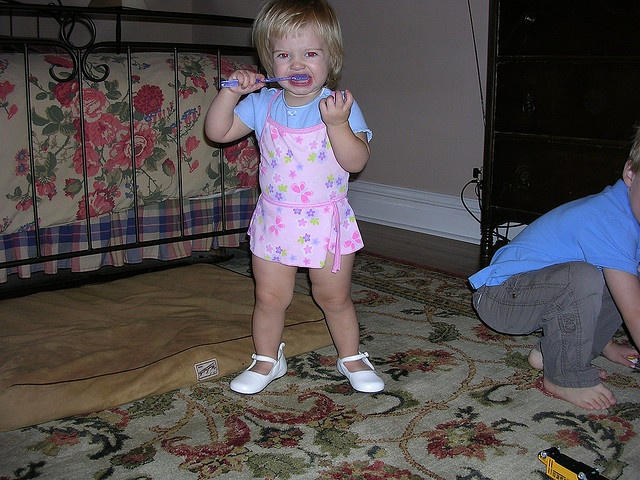Describe the objects in this image and their specific colors. I can see bed in black, gray, maroon, and brown tones, people in black, lavender, gray, and darkgray tones, people in black and gray tones, and toothbrush in black, blue, violet, purple, and navy tones in this image. 